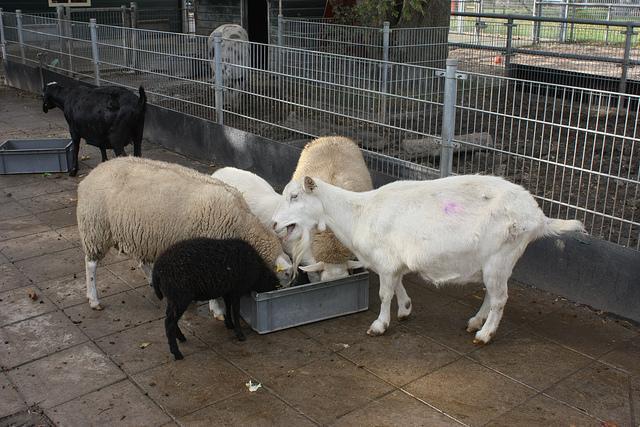Why are the animals crowded around the bucket?
Make your selection from the four choices given to correctly answer the question.
Options: To graze, to bathe, to rest, to eat. To eat. 